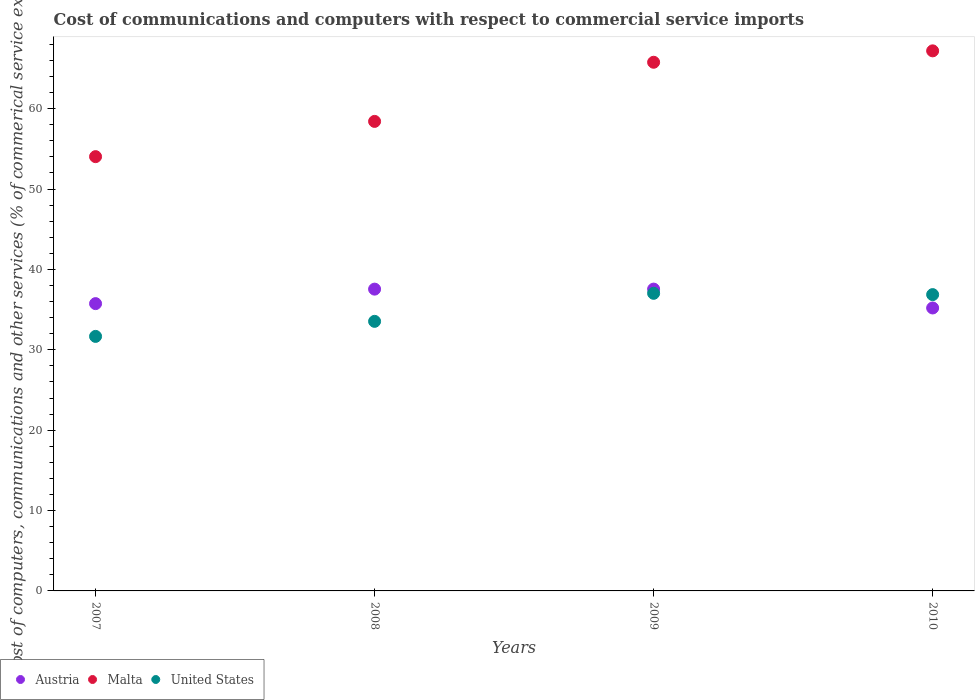Is the number of dotlines equal to the number of legend labels?
Keep it short and to the point. Yes. What is the cost of communications and computers in United States in 2009?
Provide a succinct answer. 37.03. Across all years, what is the maximum cost of communications and computers in Austria?
Your response must be concise. 37.55. Across all years, what is the minimum cost of communications and computers in Malta?
Give a very brief answer. 54.03. In which year was the cost of communications and computers in Malta maximum?
Your answer should be very brief. 2010. In which year was the cost of communications and computers in Austria minimum?
Your response must be concise. 2010. What is the total cost of communications and computers in United States in the graph?
Ensure brevity in your answer.  139.1. What is the difference between the cost of communications and computers in Austria in 2007 and that in 2010?
Offer a very short reply. 0.54. What is the difference between the cost of communications and computers in Malta in 2009 and the cost of communications and computers in United States in 2008?
Provide a short and direct response. 32.24. What is the average cost of communications and computers in Malta per year?
Your answer should be compact. 61.36. In the year 2007, what is the difference between the cost of communications and computers in Malta and cost of communications and computers in United States?
Give a very brief answer. 22.37. In how many years, is the cost of communications and computers in Austria greater than 8 %?
Give a very brief answer. 4. What is the ratio of the cost of communications and computers in Austria in 2009 to that in 2010?
Ensure brevity in your answer.  1.07. What is the difference between the highest and the second highest cost of communications and computers in Malta?
Give a very brief answer. 1.42. What is the difference between the highest and the lowest cost of communications and computers in United States?
Give a very brief answer. 5.36. In how many years, is the cost of communications and computers in Malta greater than the average cost of communications and computers in Malta taken over all years?
Make the answer very short. 2. Does the cost of communications and computers in Malta monotonically increase over the years?
Keep it short and to the point. Yes. Is the cost of communications and computers in Austria strictly greater than the cost of communications and computers in United States over the years?
Offer a terse response. No. How many dotlines are there?
Keep it short and to the point. 3. How are the legend labels stacked?
Provide a short and direct response. Horizontal. What is the title of the graph?
Your answer should be compact. Cost of communications and computers with respect to commercial service imports. What is the label or title of the X-axis?
Ensure brevity in your answer.  Years. What is the label or title of the Y-axis?
Offer a very short reply. Cost of computers, communications and other services (% of commerical service exports). What is the Cost of computers, communications and other services (% of commerical service exports) in Austria in 2007?
Offer a terse response. 35.75. What is the Cost of computers, communications and other services (% of commerical service exports) of Malta in 2007?
Ensure brevity in your answer.  54.03. What is the Cost of computers, communications and other services (% of commerical service exports) of United States in 2007?
Provide a short and direct response. 31.67. What is the Cost of computers, communications and other services (% of commerical service exports) in Austria in 2008?
Your response must be concise. 37.55. What is the Cost of computers, communications and other services (% of commerical service exports) of Malta in 2008?
Provide a succinct answer. 58.42. What is the Cost of computers, communications and other services (% of commerical service exports) in United States in 2008?
Your response must be concise. 33.54. What is the Cost of computers, communications and other services (% of commerical service exports) of Austria in 2009?
Keep it short and to the point. 37.55. What is the Cost of computers, communications and other services (% of commerical service exports) of Malta in 2009?
Ensure brevity in your answer.  65.78. What is the Cost of computers, communications and other services (% of commerical service exports) in United States in 2009?
Your answer should be compact. 37.03. What is the Cost of computers, communications and other services (% of commerical service exports) of Austria in 2010?
Offer a very short reply. 35.2. What is the Cost of computers, communications and other services (% of commerical service exports) in Malta in 2010?
Give a very brief answer. 67.2. What is the Cost of computers, communications and other services (% of commerical service exports) of United States in 2010?
Provide a succinct answer. 36.87. Across all years, what is the maximum Cost of computers, communications and other services (% of commerical service exports) of Austria?
Give a very brief answer. 37.55. Across all years, what is the maximum Cost of computers, communications and other services (% of commerical service exports) of Malta?
Offer a very short reply. 67.2. Across all years, what is the maximum Cost of computers, communications and other services (% of commerical service exports) of United States?
Provide a short and direct response. 37.03. Across all years, what is the minimum Cost of computers, communications and other services (% of commerical service exports) of Austria?
Your answer should be compact. 35.2. Across all years, what is the minimum Cost of computers, communications and other services (% of commerical service exports) in Malta?
Your response must be concise. 54.03. Across all years, what is the minimum Cost of computers, communications and other services (% of commerical service exports) in United States?
Make the answer very short. 31.67. What is the total Cost of computers, communications and other services (% of commerical service exports) of Austria in the graph?
Make the answer very short. 146.05. What is the total Cost of computers, communications and other services (% of commerical service exports) in Malta in the graph?
Make the answer very short. 245.42. What is the total Cost of computers, communications and other services (% of commerical service exports) in United States in the graph?
Your answer should be very brief. 139.1. What is the difference between the Cost of computers, communications and other services (% of commerical service exports) of Austria in 2007 and that in 2008?
Make the answer very short. -1.8. What is the difference between the Cost of computers, communications and other services (% of commerical service exports) of Malta in 2007 and that in 2008?
Your response must be concise. -4.39. What is the difference between the Cost of computers, communications and other services (% of commerical service exports) in United States in 2007 and that in 2008?
Your answer should be compact. -1.87. What is the difference between the Cost of computers, communications and other services (% of commerical service exports) in Austria in 2007 and that in 2009?
Offer a very short reply. -1.81. What is the difference between the Cost of computers, communications and other services (% of commerical service exports) of Malta in 2007 and that in 2009?
Offer a very short reply. -11.74. What is the difference between the Cost of computers, communications and other services (% of commerical service exports) in United States in 2007 and that in 2009?
Keep it short and to the point. -5.36. What is the difference between the Cost of computers, communications and other services (% of commerical service exports) of Austria in 2007 and that in 2010?
Provide a succinct answer. 0.54. What is the difference between the Cost of computers, communications and other services (% of commerical service exports) of Malta in 2007 and that in 2010?
Keep it short and to the point. -13.16. What is the difference between the Cost of computers, communications and other services (% of commerical service exports) of United States in 2007 and that in 2010?
Your answer should be compact. -5.2. What is the difference between the Cost of computers, communications and other services (% of commerical service exports) of Austria in 2008 and that in 2009?
Your response must be concise. -0. What is the difference between the Cost of computers, communications and other services (% of commerical service exports) in Malta in 2008 and that in 2009?
Provide a succinct answer. -7.36. What is the difference between the Cost of computers, communications and other services (% of commerical service exports) in United States in 2008 and that in 2009?
Give a very brief answer. -3.49. What is the difference between the Cost of computers, communications and other services (% of commerical service exports) in Austria in 2008 and that in 2010?
Your answer should be very brief. 2.34. What is the difference between the Cost of computers, communications and other services (% of commerical service exports) of Malta in 2008 and that in 2010?
Ensure brevity in your answer.  -8.78. What is the difference between the Cost of computers, communications and other services (% of commerical service exports) in United States in 2008 and that in 2010?
Your answer should be compact. -3.33. What is the difference between the Cost of computers, communications and other services (% of commerical service exports) in Austria in 2009 and that in 2010?
Provide a succinct answer. 2.35. What is the difference between the Cost of computers, communications and other services (% of commerical service exports) in Malta in 2009 and that in 2010?
Ensure brevity in your answer.  -1.42. What is the difference between the Cost of computers, communications and other services (% of commerical service exports) in United States in 2009 and that in 2010?
Offer a terse response. 0.16. What is the difference between the Cost of computers, communications and other services (% of commerical service exports) in Austria in 2007 and the Cost of computers, communications and other services (% of commerical service exports) in Malta in 2008?
Provide a succinct answer. -22.67. What is the difference between the Cost of computers, communications and other services (% of commerical service exports) in Austria in 2007 and the Cost of computers, communications and other services (% of commerical service exports) in United States in 2008?
Offer a very short reply. 2.21. What is the difference between the Cost of computers, communications and other services (% of commerical service exports) in Malta in 2007 and the Cost of computers, communications and other services (% of commerical service exports) in United States in 2008?
Keep it short and to the point. 20.49. What is the difference between the Cost of computers, communications and other services (% of commerical service exports) in Austria in 2007 and the Cost of computers, communications and other services (% of commerical service exports) in Malta in 2009?
Your response must be concise. -30.03. What is the difference between the Cost of computers, communications and other services (% of commerical service exports) of Austria in 2007 and the Cost of computers, communications and other services (% of commerical service exports) of United States in 2009?
Your response must be concise. -1.28. What is the difference between the Cost of computers, communications and other services (% of commerical service exports) in Malta in 2007 and the Cost of computers, communications and other services (% of commerical service exports) in United States in 2009?
Make the answer very short. 17.01. What is the difference between the Cost of computers, communications and other services (% of commerical service exports) in Austria in 2007 and the Cost of computers, communications and other services (% of commerical service exports) in Malta in 2010?
Keep it short and to the point. -31.45. What is the difference between the Cost of computers, communications and other services (% of commerical service exports) in Austria in 2007 and the Cost of computers, communications and other services (% of commerical service exports) in United States in 2010?
Provide a succinct answer. -1.12. What is the difference between the Cost of computers, communications and other services (% of commerical service exports) in Malta in 2007 and the Cost of computers, communications and other services (% of commerical service exports) in United States in 2010?
Offer a terse response. 17.17. What is the difference between the Cost of computers, communications and other services (% of commerical service exports) in Austria in 2008 and the Cost of computers, communications and other services (% of commerical service exports) in Malta in 2009?
Provide a short and direct response. -28.23. What is the difference between the Cost of computers, communications and other services (% of commerical service exports) in Austria in 2008 and the Cost of computers, communications and other services (% of commerical service exports) in United States in 2009?
Provide a succinct answer. 0.52. What is the difference between the Cost of computers, communications and other services (% of commerical service exports) in Malta in 2008 and the Cost of computers, communications and other services (% of commerical service exports) in United States in 2009?
Make the answer very short. 21.39. What is the difference between the Cost of computers, communications and other services (% of commerical service exports) of Austria in 2008 and the Cost of computers, communications and other services (% of commerical service exports) of Malta in 2010?
Give a very brief answer. -29.65. What is the difference between the Cost of computers, communications and other services (% of commerical service exports) in Austria in 2008 and the Cost of computers, communications and other services (% of commerical service exports) in United States in 2010?
Offer a very short reply. 0.68. What is the difference between the Cost of computers, communications and other services (% of commerical service exports) of Malta in 2008 and the Cost of computers, communications and other services (% of commerical service exports) of United States in 2010?
Keep it short and to the point. 21.55. What is the difference between the Cost of computers, communications and other services (% of commerical service exports) of Austria in 2009 and the Cost of computers, communications and other services (% of commerical service exports) of Malta in 2010?
Your answer should be compact. -29.64. What is the difference between the Cost of computers, communications and other services (% of commerical service exports) in Austria in 2009 and the Cost of computers, communications and other services (% of commerical service exports) in United States in 2010?
Keep it short and to the point. 0.69. What is the difference between the Cost of computers, communications and other services (% of commerical service exports) in Malta in 2009 and the Cost of computers, communications and other services (% of commerical service exports) in United States in 2010?
Your answer should be compact. 28.91. What is the average Cost of computers, communications and other services (% of commerical service exports) in Austria per year?
Your response must be concise. 36.51. What is the average Cost of computers, communications and other services (% of commerical service exports) in Malta per year?
Your response must be concise. 61.36. What is the average Cost of computers, communications and other services (% of commerical service exports) of United States per year?
Make the answer very short. 34.78. In the year 2007, what is the difference between the Cost of computers, communications and other services (% of commerical service exports) of Austria and Cost of computers, communications and other services (% of commerical service exports) of Malta?
Provide a short and direct response. -18.29. In the year 2007, what is the difference between the Cost of computers, communications and other services (% of commerical service exports) of Austria and Cost of computers, communications and other services (% of commerical service exports) of United States?
Give a very brief answer. 4.08. In the year 2007, what is the difference between the Cost of computers, communications and other services (% of commerical service exports) in Malta and Cost of computers, communications and other services (% of commerical service exports) in United States?
Provide a succinct answer. 22.37. In the year 2008, what is the difference between the Cost of computers, communications and other services (% of commerical service exports) of Austria and Cost of computers, communications and other services (% of commerical service exports) of Malta?
Keep it short and to the point. -20.87. In the year 2008, what is the difference between the Cost of computers, communications and other services (% of commerical service exports) of Austria and Cost of computers, communications and other services (% of commerical service exports) of United States?
Make the answer very short. 4.01. In the year 2008, what is the difference between the Cost of computers, communications and other services (% of commerical service exports) of Malta and Cost of computers, communications and other services (% of commerical service exports) of United States?
Keep it short and to the point. 24.88. In the year 2009, what is the difference between the Cost of computers, communications and other services (% of commerical service exports) in Austria and Cost of computers, communications and other services (% of commerical service exports) in Malta?
Your answer should be compact. -28.22. In the year 2009, what is the difference between the Cost of computers, communications and other services (% of commerical service exports) of Austria and Cost of computers, communications and other services (% of commerical service exports) of United States?
Give a very brief answer. 0.53. In the year 2009, what is the difference between the Cost of computers, communications and other services (% of commerical service exports) in Malta and Cost of computers, communications and other services (% of commerical service exports) in United States?
Keep it short and to the point. 28.75. In the year 2010, what is the difference between the Cost of computers, communications and other services (% of commerical service exports) of Austria and Cost of computers, communications and other services (% of commerical service exports) of Malta?
Offer a very short reply. -31.99. In the year 2010, what is the difference between the Cost of computers, communications and other services (% of commerical service exports) of Austria and Cost of computers, communications and other services (% of commerical service exports) of United States?
Provide a succinct answer. -1.66. In the year 2010, what is the difference between the Cost of computers, communications and other services (% of commerical service exports) of Malta and Cost of computers, communications and other services (% of commerical service exports) of United States?
Make the answer very short. 30.33. What is the ratio of the Cost of computers, communications and other services (% of commerical service exports) of Malta in 2007 to that in 2008?
Ensure brevity in your answer.  0.92. What is the ratio of the Cost of computers, communications and other services (% of commerical service exports) in United States in 2007 to that in 2008?
Your answer should be very brief. 0.94. What is the ratio of the Cost of computers, communications and other services (% of commerical service exports) of Austria in 2007 to that in 2009?
Provide a succinct answer. 0.95. What is the ratio of the Cost of computers, communications and other services (% of commerical service exports) in Malta in 2007 to that in 2009?
Your response must be concise. 0.82. What is the ratio of the Cost of computers, communications and other services (% of commerical service exports) in United States in 2007 to that in 2009?
Your answer should be compact. 0.86. What is the ratio of the Cost of computers, communications and other services (% of commerical service exports) of Austria in 2007 to that in 2010?
Provide a short and direct response. 1.02. What is the ratio of the Cost of computers, communications and other services (% of commerical service exports) of Malta in 2007 to that in 2010?
Provide a succinct answer. 0.8. What is the ratio of the Cost of computers, communications and other services (% of commerical service exports) of United States in 2007 to that in 2010?
Make the answer very short. 0.86. What is the ratio of the Cost of computers, communications and other services (% of commerical service exports) in Malta in 2008 to that in 2009?
Provide a short and direct response. 0.89. What is the ratio of the Cost of computers, communications and other services (% of commerical service exports) in United States in 2008 to that in 2009?
Make the answer very short. 0.91. What is the ratio of the Cost of computers, communications and other services (% of commerical service exports) of Austria in 2008 to that in 2010?
Offer a terse response. 1.07. What is the ratio of the Cost of computers, communications and other services (% of commerical service exports) of Malta in 2008 to that in 2010?
Your answer should be very brief. 0.87. What is the ratio of the Cost of computers, communications and other services (% of commerical service exports) in United States in 2008 to that in 2010?
Ensure brevity in your answer.  0.91. What is the ratio of the Cost of computers, communications and other services (% of commerical service exports) in Austria in 2009 to that in 2010?
Give a very brief answer. 1.07. What is the ratio of the Cost of computers, communications and other services (% of commerical service exports) in Malta in 2009 to that in 2010?
Give a very brief answer. 0.98. What is the ratio of the Cost of computers, communications and other services (% of commerical service exports) in United States in 2009 to that in 2010?
Provide a short and direct response. 1. What is the difference between the highest and the second highest Cost of computers, communications and other services (% of commerical service exports) in Austria?
Your response must be concise. 0. What is the difference between the highest and the second highest Cost of computers, communications and other services (% of commerical service exports) in Malta?
Make the answer very short. 1.42. What is the difference between the highest and the second highest Cost of computers, communications and other services (% of commerical service exports) in United States?
Your answer should be very brief. 0.16. What is the difference between the highest and the lowest Cost of computers, communications and other services (% of commerical service exports) in Austria?
Give a very brief answer. 2.35. What is the difference between the highest and the lowest Cost of computers, communications and other services (% of commerical service exports) in Malta?
Provide a short and direct response. 13.16. What is the difference between the highest and the lowest Cost of computers, communications and other services (% of commerical service exports) of United States?
Your answer should be very brief. 5.36. 